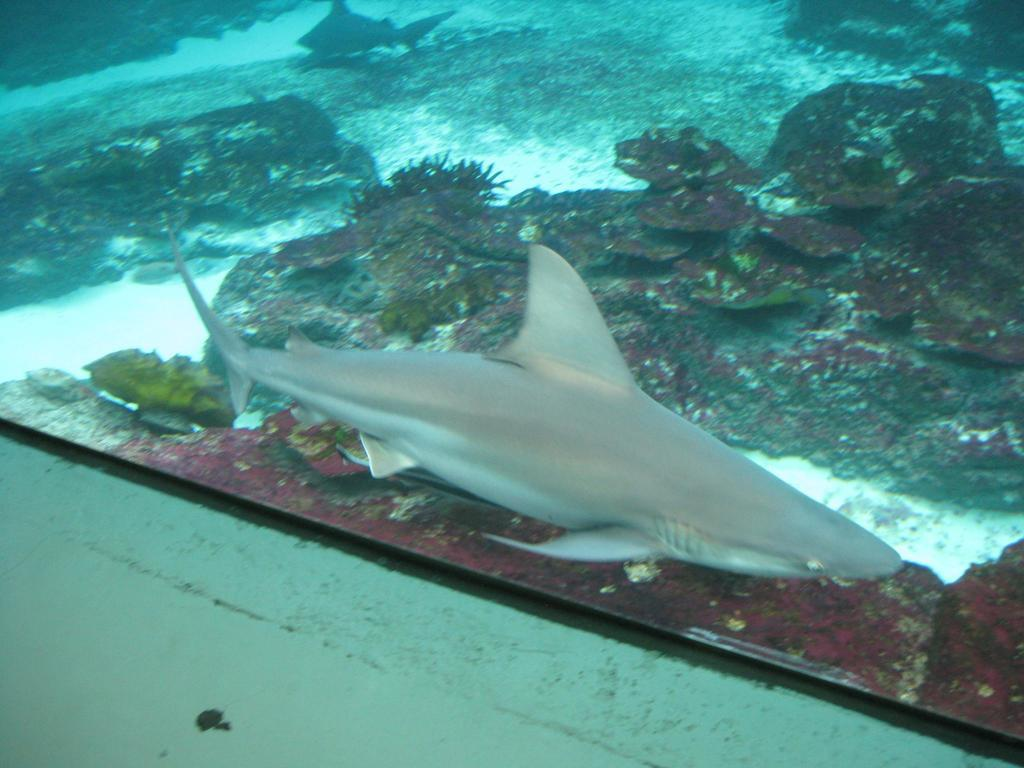What is the setting of the image? The image is taken underwater. What type of marine animal can be seen in the image? There is a shark in the image. What other marine life can be seen in the image? There are fish in the image. What type of vegetation is present in the image? There are aquatic plants in the image. Can you tell me what time of day the goat is visible in the image? There is no goat present in the image, and therefore no such activity can be observed. What type of camera is being used to take the image? The image does not provide information about the camera used to take the image. 